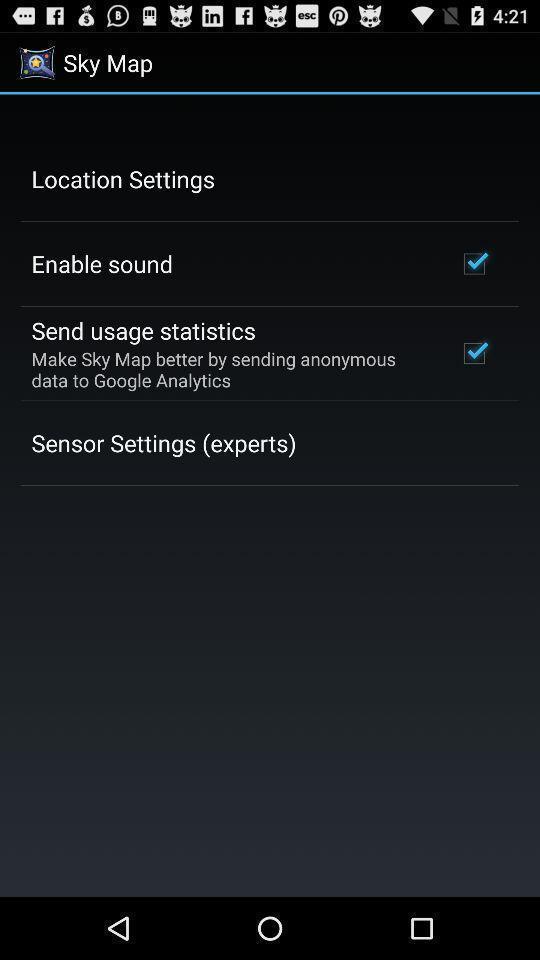What can you discern from this picture? Settings in the map application. 